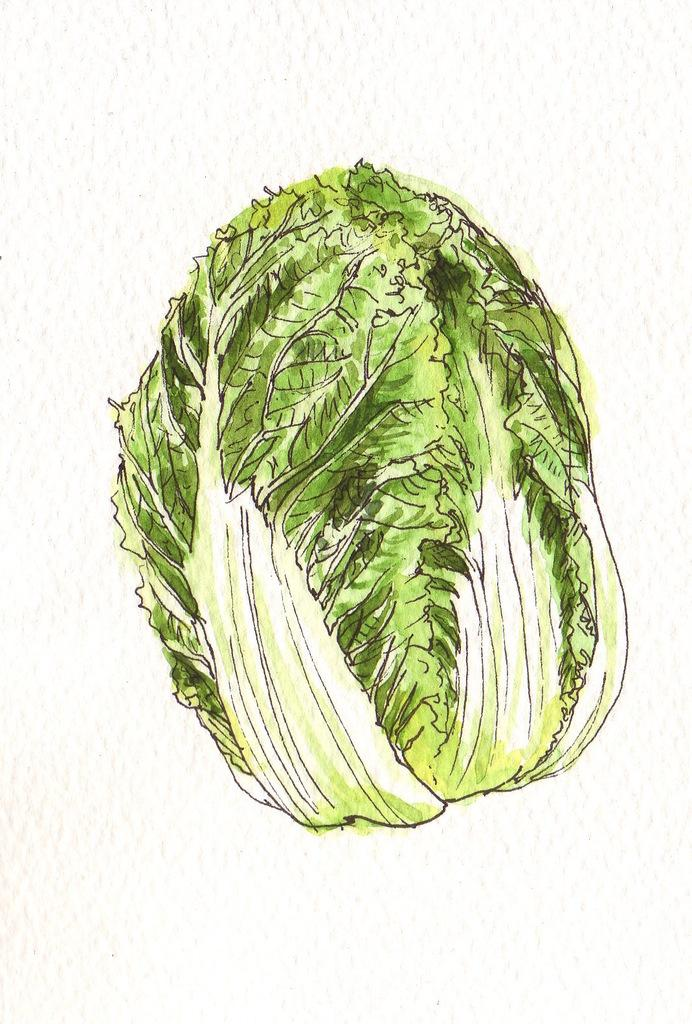What is depicted on the table in the image? There is cabbage drawn on a table in the image. What color is the cabbage in the image? The cabbage is green in color. What color is the background of the image? The background of the image is white. What room is the cabbage located in the image? The image does not provide information about the room or location where the cabbage is drawn. 